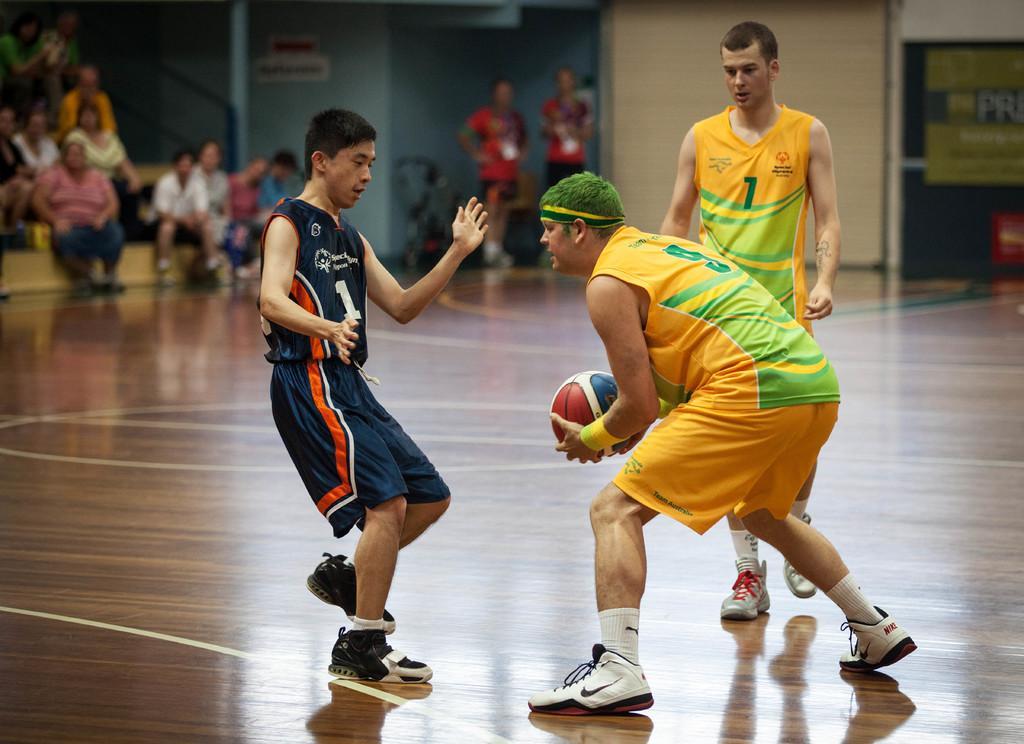Describe this image in one or two sentences. There are three people playing basketball. One person is holding a ball. In the back there are many people sitting. Two persons are standing. Also there is wall. 